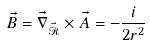Convert formula to latex. <formula><loc_0><loc_0><loc_500><loc_500>\vec { B } = \vec { \nabla } _ { \vec { \mathcal { R } } } \times \vec { A } = - \frac { i } { 2 r ^ { 2 } }</formula> 